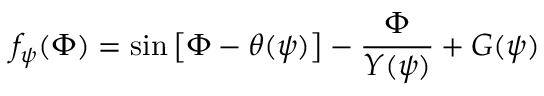<formula> <loc_0><loc_0><loc_500><loc_500>f _ { \psi } ( \Phi ) = \sin \left [ \Phi - \theta ( \psi ) \right ] - \frac { \Phi } { Y ( \psi ) } + G ( \psi )</formula> 